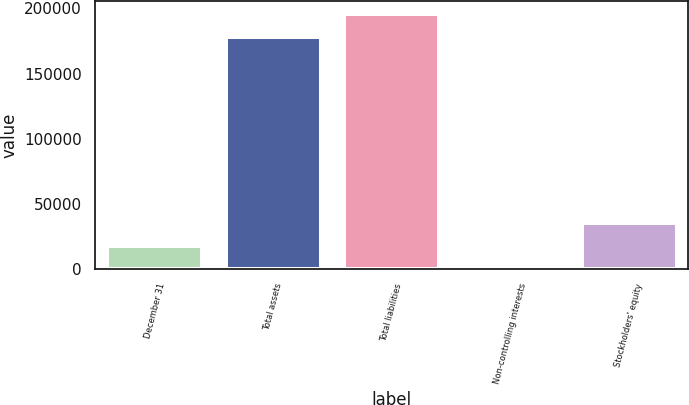<chart> <loc_0><loc_0><loc_500><loc_500><bar_chart><fcel>December 31<fcel>Total assets<fcel>Total liabilities<fcel>Non-controlling interests<fcel>Stockholders' equity<nl><fcel>18045.1<fcel>177994<fcel>195766<fcel>273<fcel>35817.2<nl></chart> 